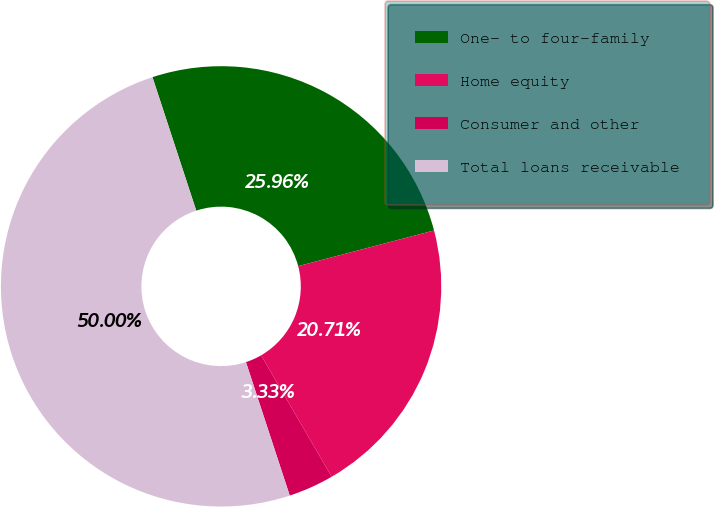Convert chart to OTSL. <chart><loc_0><loc_0><loc_500><loc_500><pie_chart><fcel>One- to four-family<fcel>Home equity<fcel>Consumer and other<fcel>Total loans receivable<nl><fcel>25.96%<fcel>20.71%<fcel>3.33%<fcel>50.0%<nl></chart> 